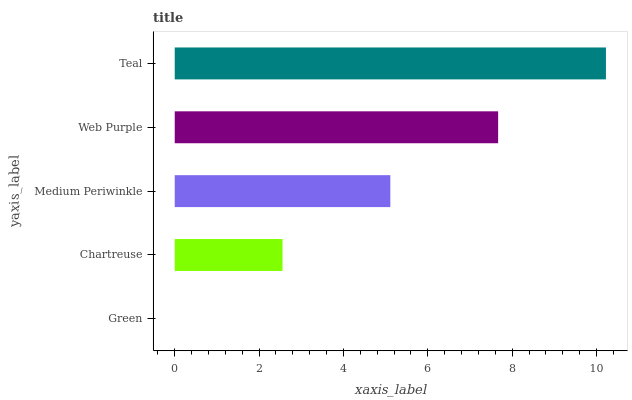Is Green the minimum?
Answer yes or no. Yes. Is Teal the maximum?
Answer yes or no. Yes. Is Chartreuse the minimum?
Answer yes or no. No. Is Chartreuse the maximum?
Answer yes or no. No. Is Chartreuse greater than Green?
Answer yes or no. Yes. Is Green less than Chartreuse?
Answer yes or no. Yes. Is Green greater than Chartreuse?
Answer yes or no. No. Is Chartreuse less than Green?
Answer yes or no. No. Is Medium Periwinkle the high median?
Answer yes or no. Yes. Is Medium Periwinkle the low median?
Answer yes or no. Yes. Is Teal the high median?
Answer yes or no. No. Is Web Purple the low median?
Answer yes or no. No. 